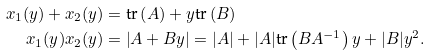Convert formula to latex. <formula><loc_0><loc_0><loc_500><loc_500>x _ { 1 } ( y ) + x _ { 2 } ( y ) & = \text {tr} \left ( A \right ) + y \text {tr} \left ( B \right ) \\ x _ { 1 } ( y ) x _ { 2 } ( y ) & = \left | A + B y \right | = | A | + | A | \text {tr} \left ( B A ^ { - 1 } \right ) y + | B | y ^ { 2 } .</formula> 